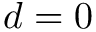Convert formula to latex. <formula><loc_0><loc_0><loc_500><loc_500>d = 0</formula> 